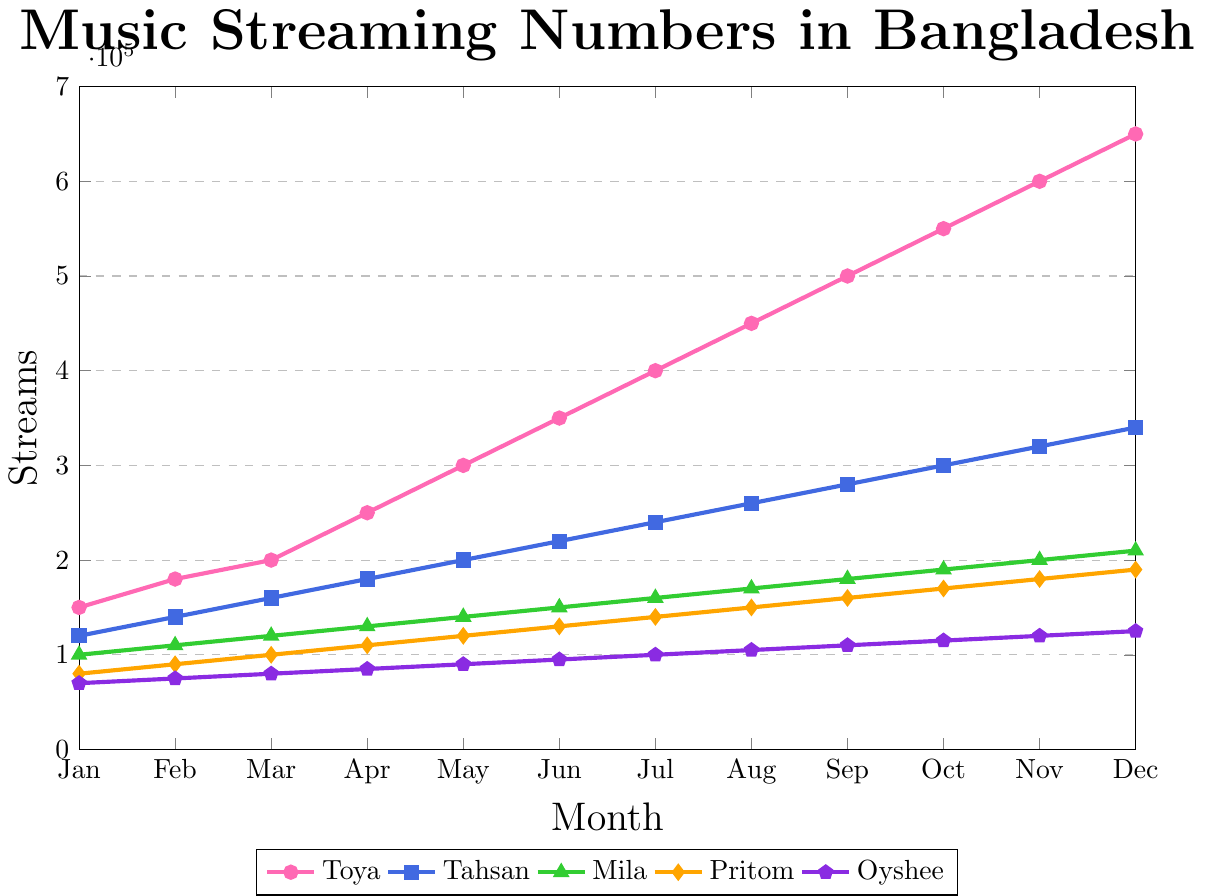Which artist has the highest streaming numbers in December 2023? From the figure, you can see the final data points for December 2023. Toya's data point is the highest at 650,000 streams.
Answer: Toya How many more streams did Toya have in May 2023 compared to Tahsan? In May 2023, Toya had 300,000 streams and Tahsan had 200,000 streams. The difference is calculated as 300,000 - 200,000 = 100,000.
Answer: 100,000 What is the average monthly streaming growth for Toya from January to December 2023? Toya's streaming numbers increased from 150,000 in January to 650,000 in December. The total increase is 650,000 - 150,000 = 500,000. Over 11 months (from January to December), the average monthly growth is 500,000 / 11 ≈ 45,455.
Answer: 45,455 In which month did Oyshee's streaming numbers surpass 100,000? By examining Oyshee's data points, the month where streaming numbers first exceed 100,000 is July 2023, which corresponds to 100,000 streams.
Answer: July Compare the streaming numbers of Toya and Mila in July 2023. Who had more streams, and by how much? In July, Toya had 400,000 streams, while Mila had 160,000 streams. The difference is 400,000 - 160,000 = 240,000, with Toya having more streams.
Answer: Toya by 240,000 Calculate the total number of streams for Pritom from January to December 2023. Pritom's streaming numbers are: 80,000, 90,000, 100,000, 110,000, 120,000, 130,000, 140,000, 150,000, 160,000, 170,000, 180,000, 190,000. The sum is 80,000 + 90,000 + 100,000 + 110,000 + 120,000 + 130,000 + 140,000 + 150,000 + 160,000 + 170,000 + 180,000 + 190,000 = 1,720,000.
Answer: 1,720,000 Which artist had the least growth in streaming numbers from January to December 2023? By examining the streaming numbers, the least growth is observed in Oyshee's data, growing from 70,000 in January to 125,000 in December, a difference of 55,000. The other artists had higher absolute growth.
Answer: Oyshee What color represents Tahsan's streaming numbers in the chart? Tahsan's line is represented by a blue color in the chart.
Answer: Blue 